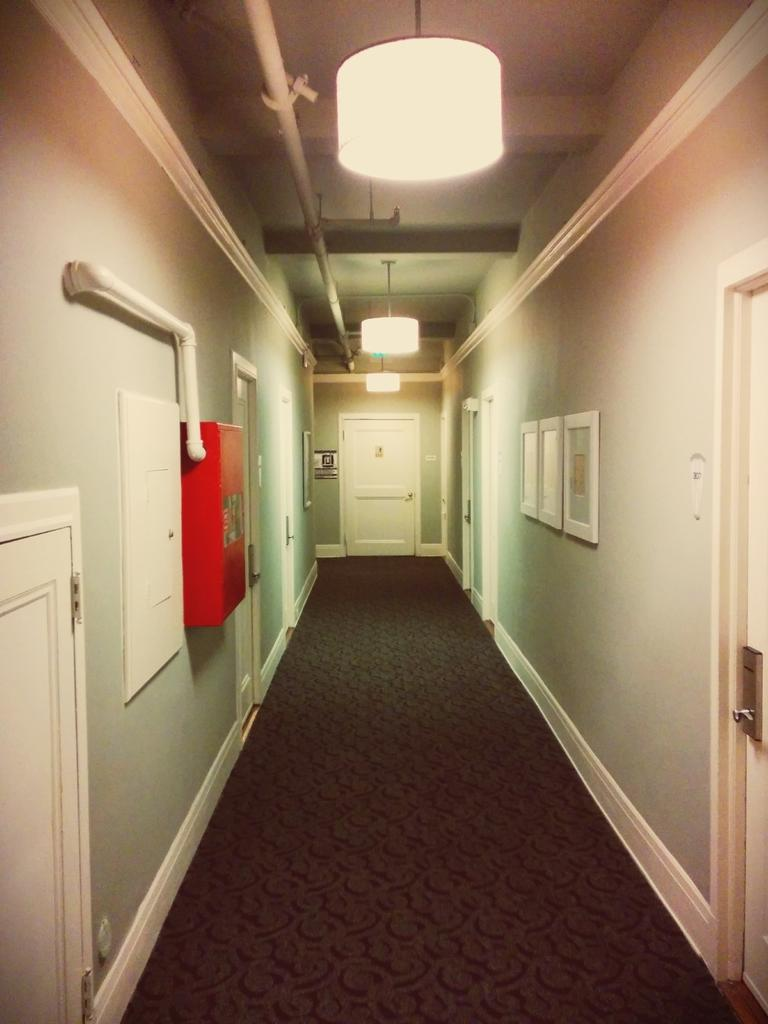What type of location is depicted in the image? The image is an inside view of a building. What are some features of the building that can be seen in the image? There are doors, frames on the walls, pipes, a roof, and ceiling lights visible in the image. Can you tell me how many teeth the monkey has in the image? There is no monkey present in the image, and therefore no teeth can be observed. What type of drink is being served in the building? The image does not show any drinks being served, so it cannot be determined from the picture. 